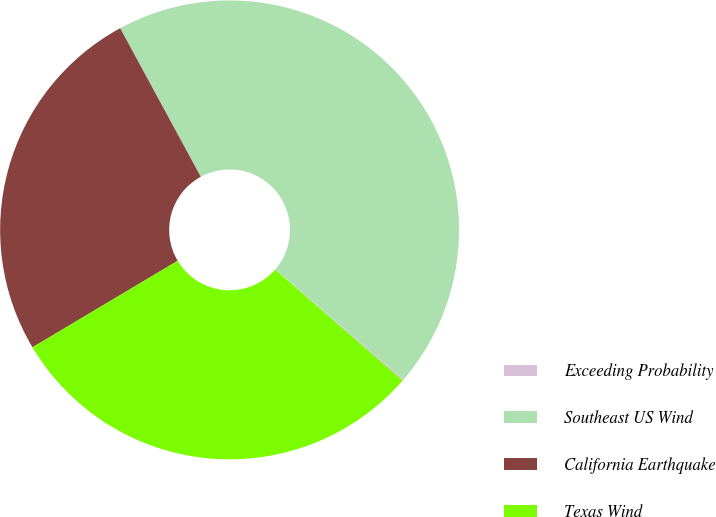Convert chart to OTSL. <chart><loc_0><loc_0><loc_500><loc_500><pie_chart><fcel>Exceeding Probability<fcel>Southeast US Wind<fcel>California Earthquake<fcel>Texas Wind<nl><fcel>0.11%<fcel>44.2%<fcel>25.64%<fcel>30.05%<nl></chart> 